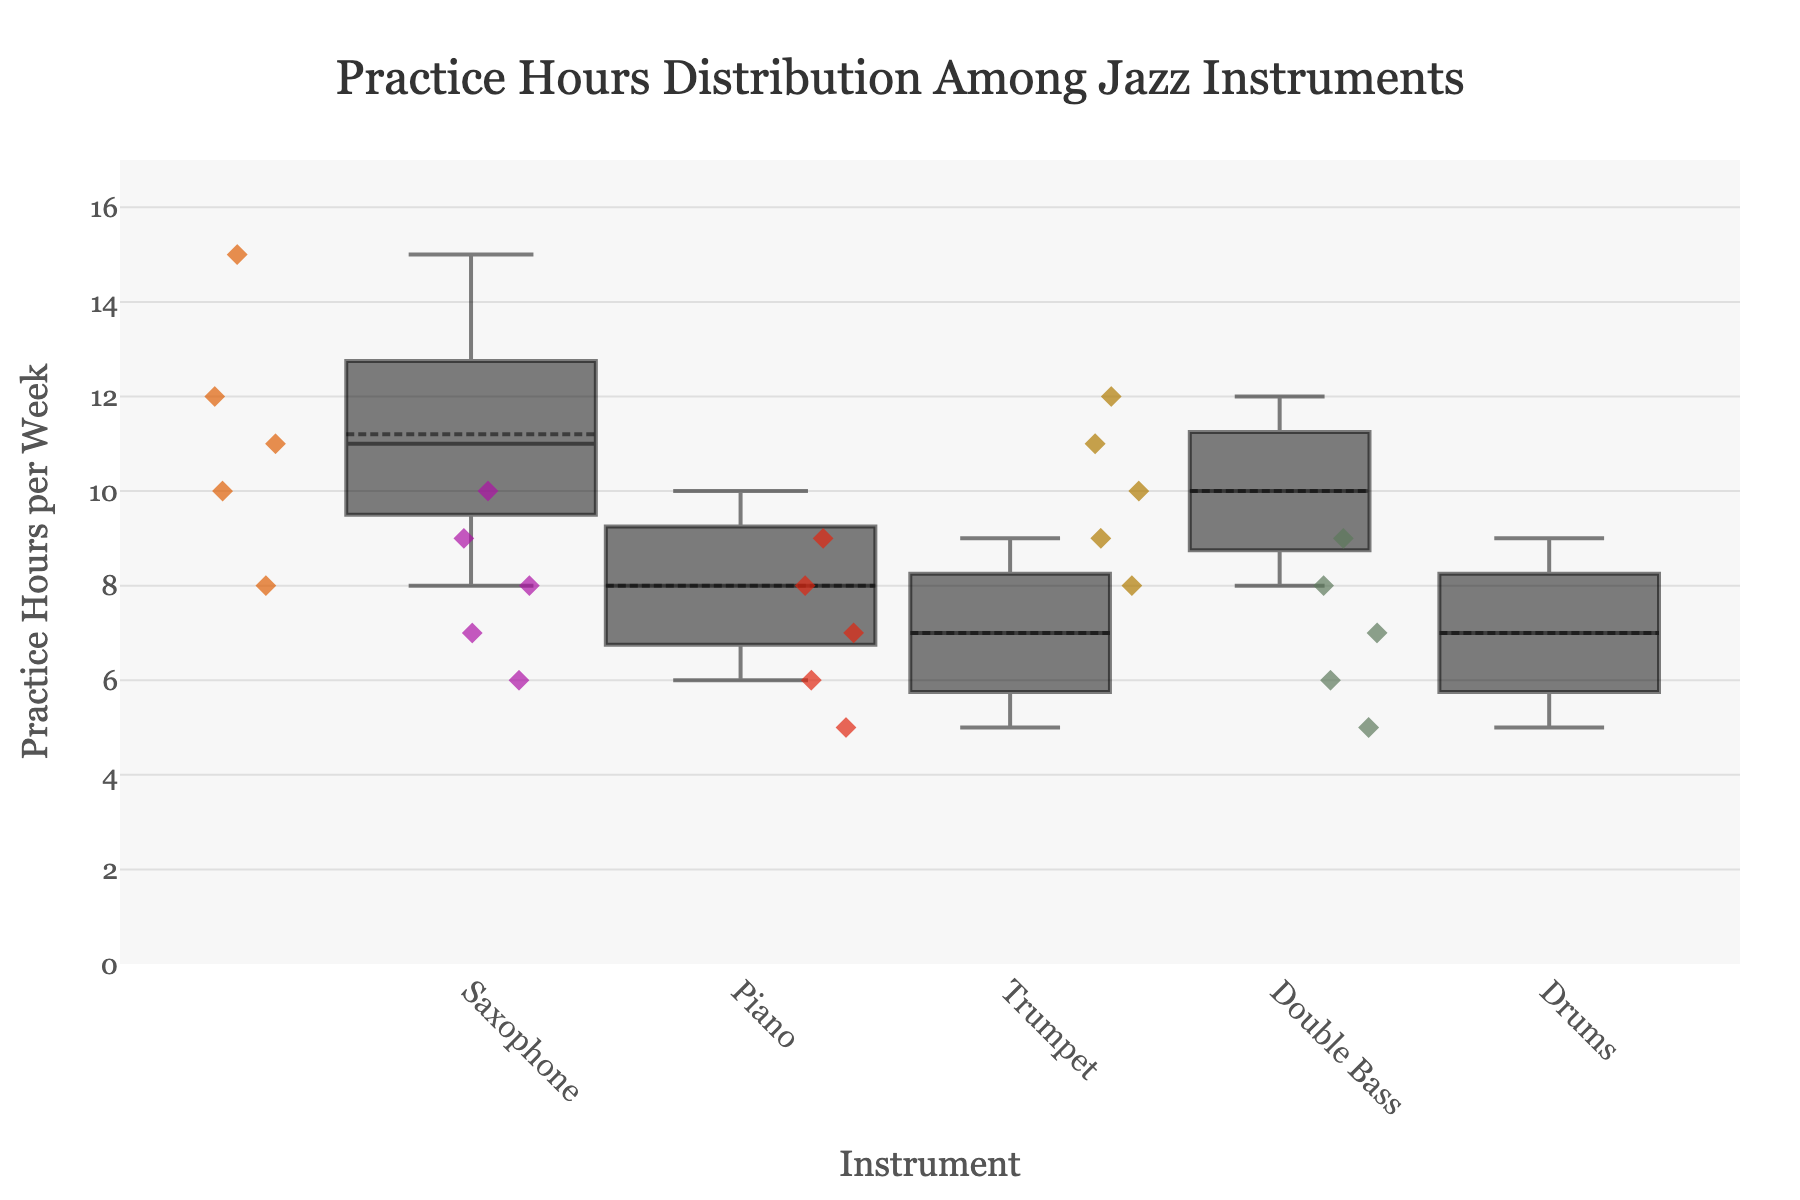What is the title of the plot? The title is typically placed at the top of the plot in a larger font for easy identification, and it describes the overall content of the figure. Here, it specifies the context of the data.
Answer: Practice Hours Distribution Among Jazz Instruments How many different instruments are compared in the plot? The plot compares different jazz instruments, each represented by a separate box. By counting the number of unique boxes in the plot, we can determine the number of instruments compared.
Answer: 5 Which instrument has the widest box and why? The width of each box correlates with the number of students for that instrument. Observing the boxes horizontally and identifying the widest one will reveal the instrument with the most students.
Answer: Piano What's the interquartile range of practice hours for the saxophone students? The interquartile range (IQR) is the range between the first quartile (Q1) and the third quartile (Q3). For the saxophone, finding the middle 50% range of practice hours from the box edges will give the IQR.
Answer: 4 (range from 9 to 13 hours) Which instrument has the smallest median practice hours per week? The median, represented typically by a line inside the box, indicates the middle value of practice hours for each instrument. Identifying the smallest median by comparing the lines in each box reveals the answer.
Answer: Drums Are there any outliers in the piano practice hours data? Outliers are data points that fall outside the whiskers of the box plot. By examining the points beyond the whiskers for the piano, we can identify if outliers exist.
Answer: No Compare the range of practice hours for trumpet and drums. Which one is larger? The range is the difference between the maximum and minimum values of practice hours. By measuring the span of the whiskers for both instruments and comparing the two ranges, the instrument with the larger range can be identified.
Answer: Trumpet What is the average practice hours for double bass students? The average can be calculated by summing up all hours per week for double bass students and dividing by the number of students. Summing (9 + 10 + 12 + 8 + 11) and dividing by 18 gives the average.
Answer: 10.8 How does the variability of practice hours for the saxophone compare to the drums? Variability can be assessed by looking at the spread of the data within the boxes and whiskers. Comparing the spread of practice hours between saxophone and drums will show how the variability differs.
Answer: Saxophone has greater variability Which instrument's students practice the most on average? The mean value for each instrument can be identified by observing the horizontal line or other marker within each box if it indicates the average. The instrument with the highest average can then be determined.
Answer: Saxophone 